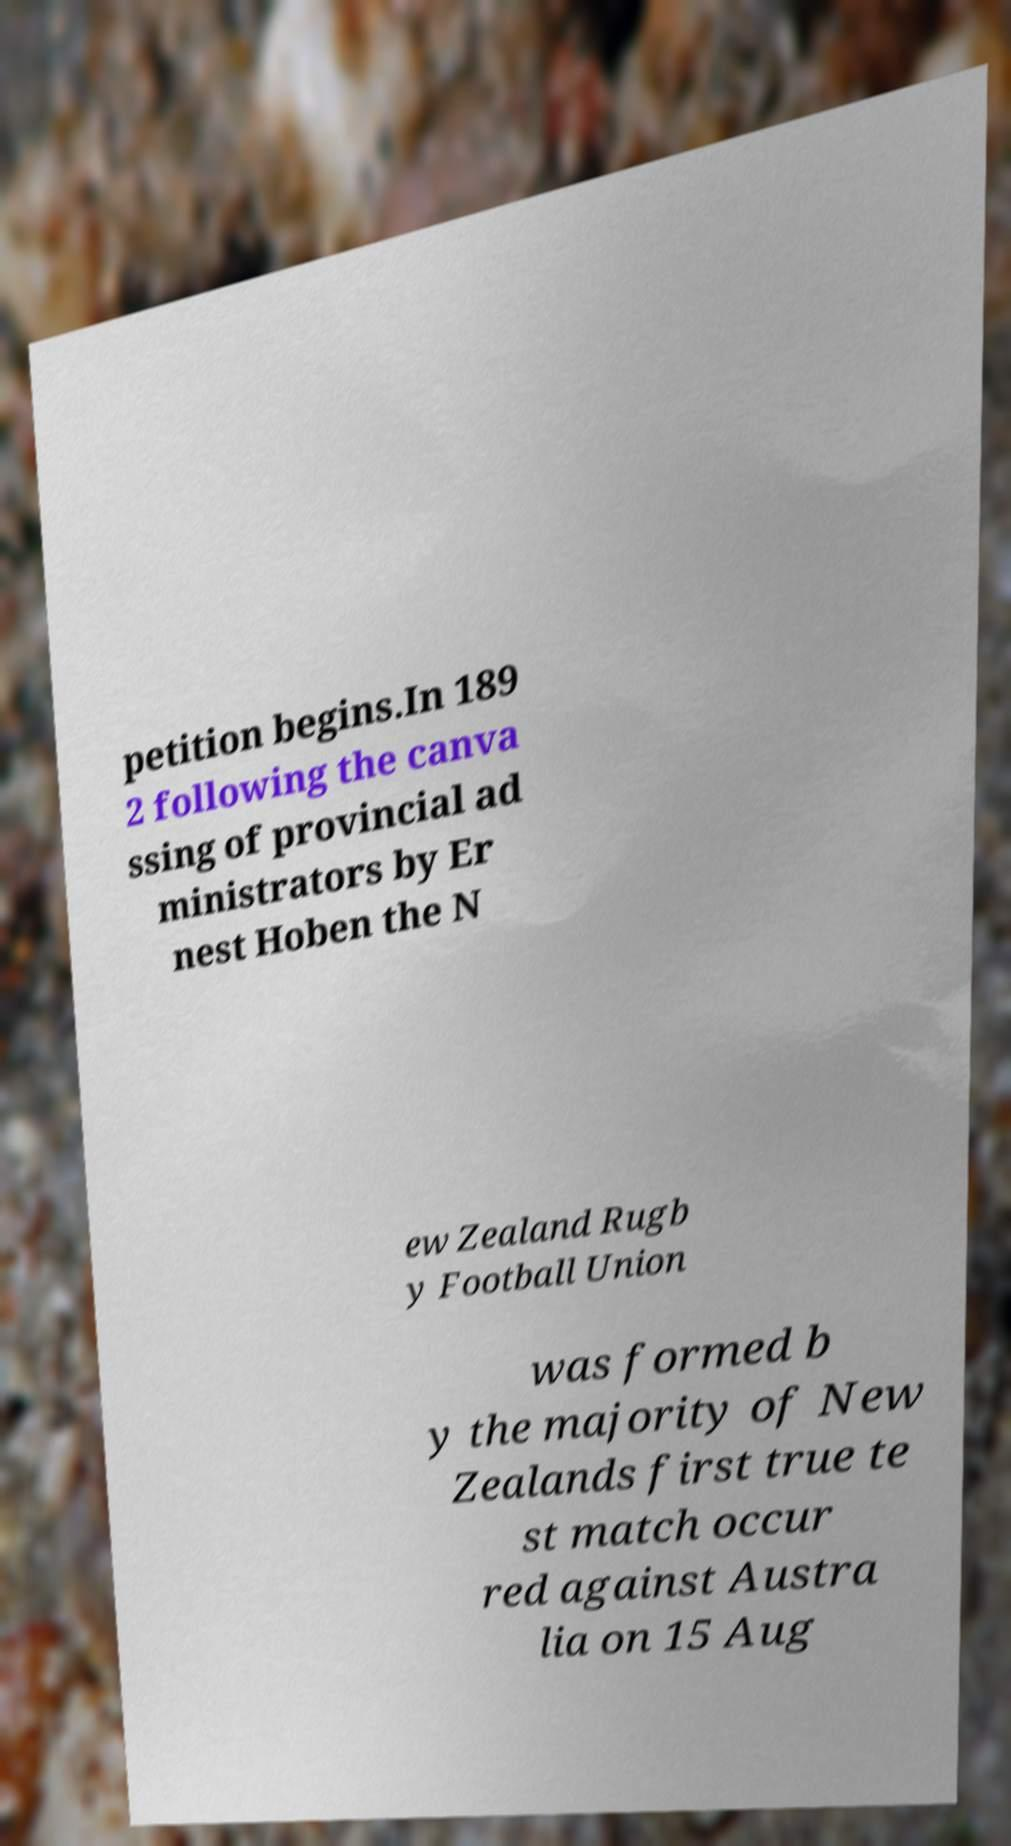Please read and relay the text visible in this image. What does it say? petition begins.In 189 2 following the canva ssing of provincial ad ministrators by Er nest Hoben the N ew Zealand Rugb y Football Union was formed b y the majority of New Zealands first true te st match occur red against Austra lia on 15 Aug 